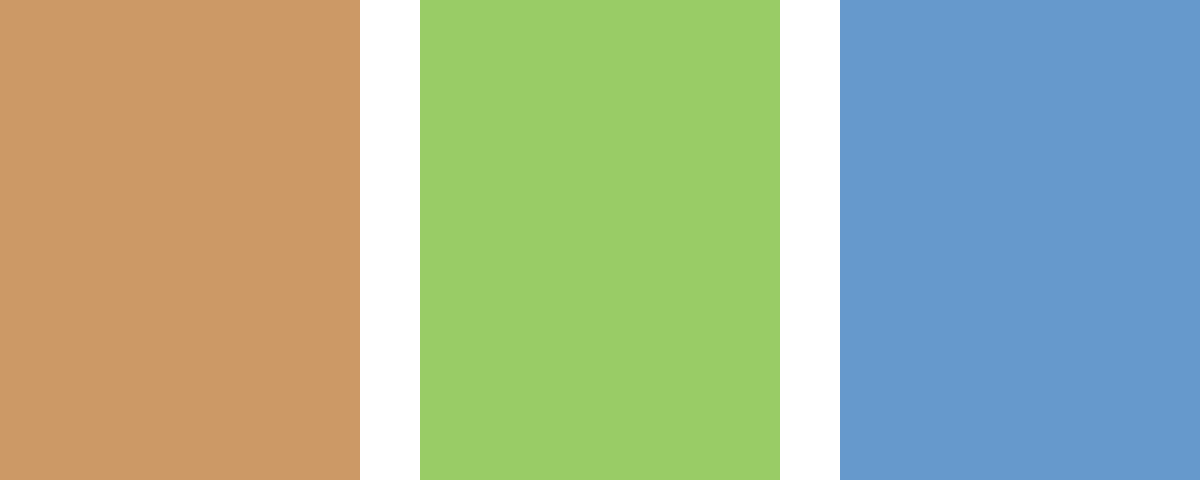Analyze the evolution of visual symbolism in the book cover designs for Ray Bradbury's "The Illustrated Man" across different decades, as represented in the image. How do these changes reflect shifts in literary interpretation and design trends? 1. 1950s edition (left):
   - Features a simple blue circle, representing the minimalist approach of early sci-fi cover designs.
   - The circle symbolizes the circular tattoos on the Illustrated Man's body, which contain the stories.
   - Blue color suggests mystery and the unknown, fitting for the era's fascination with space exploration.

2. 1980s edition (center):
   - Displays a red triangle, indicating a shift towards more abstract and geometric designs.
   - The triangle could represent the three-act structure of storytelling or the triad of past, present, and future in Bradbury's tales.
   - Red color evokes intensity and emotion, reflecting the psychological depth of the stories.

3. 2010s edition (right):
   - Shows a green spiral or vortex, suggesting a more complex and dynamic interpretation of the book.
   - The spiral symbolizes the interconnectedness of the stories and the cyclical nature of human experience.
   - Green color may represent growth, renewal, or the increasing relevance of environmental themes in modern interpretations of Bradbury's work.

4. Overall evolution:
   - Progression from simple to complex shapes reflects growing sophistication in graphic design and book marketing.
   - Color shifts from cool (blue) to warm (red) to natural (green) mirror changing cultural aesthetics and interpretations of science fiction.
   - Increasing abstraction in symbols suggests a move towards more interpretive and conceptual representations of the book's themes.

5. Reflection of literary interpretation:
   - Early focus on the visual concept of the tattoos gives way to more abstract representations of the book's themes and structure.
   - Later designs invite more reader interpretation, aligning with post-modern approaches to literature.

6. Design trends:
   - Mirrors the evolution from literal illustrations to conceptual art in book cover design.
   - Reflects the increasing use of symbolism and abstraction in visual communication over time.
Answer: Evolution from literal (circle/tattoos) to abstract (triangle/structure) to conceptual (spiral/interconnectedness) symbolism, reflecting changing literary interpretations and design trends. 